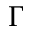Convert formula to latex. <formula><loc_0><loc_0><loc_500><loc_500>\Gamma</formula> 